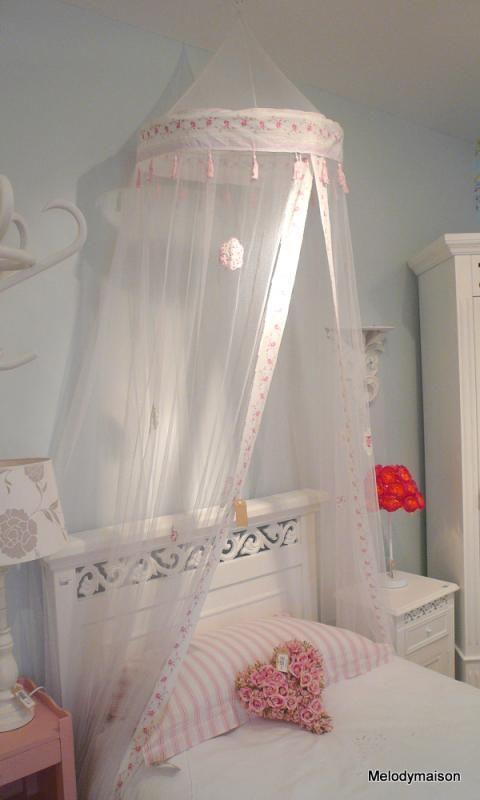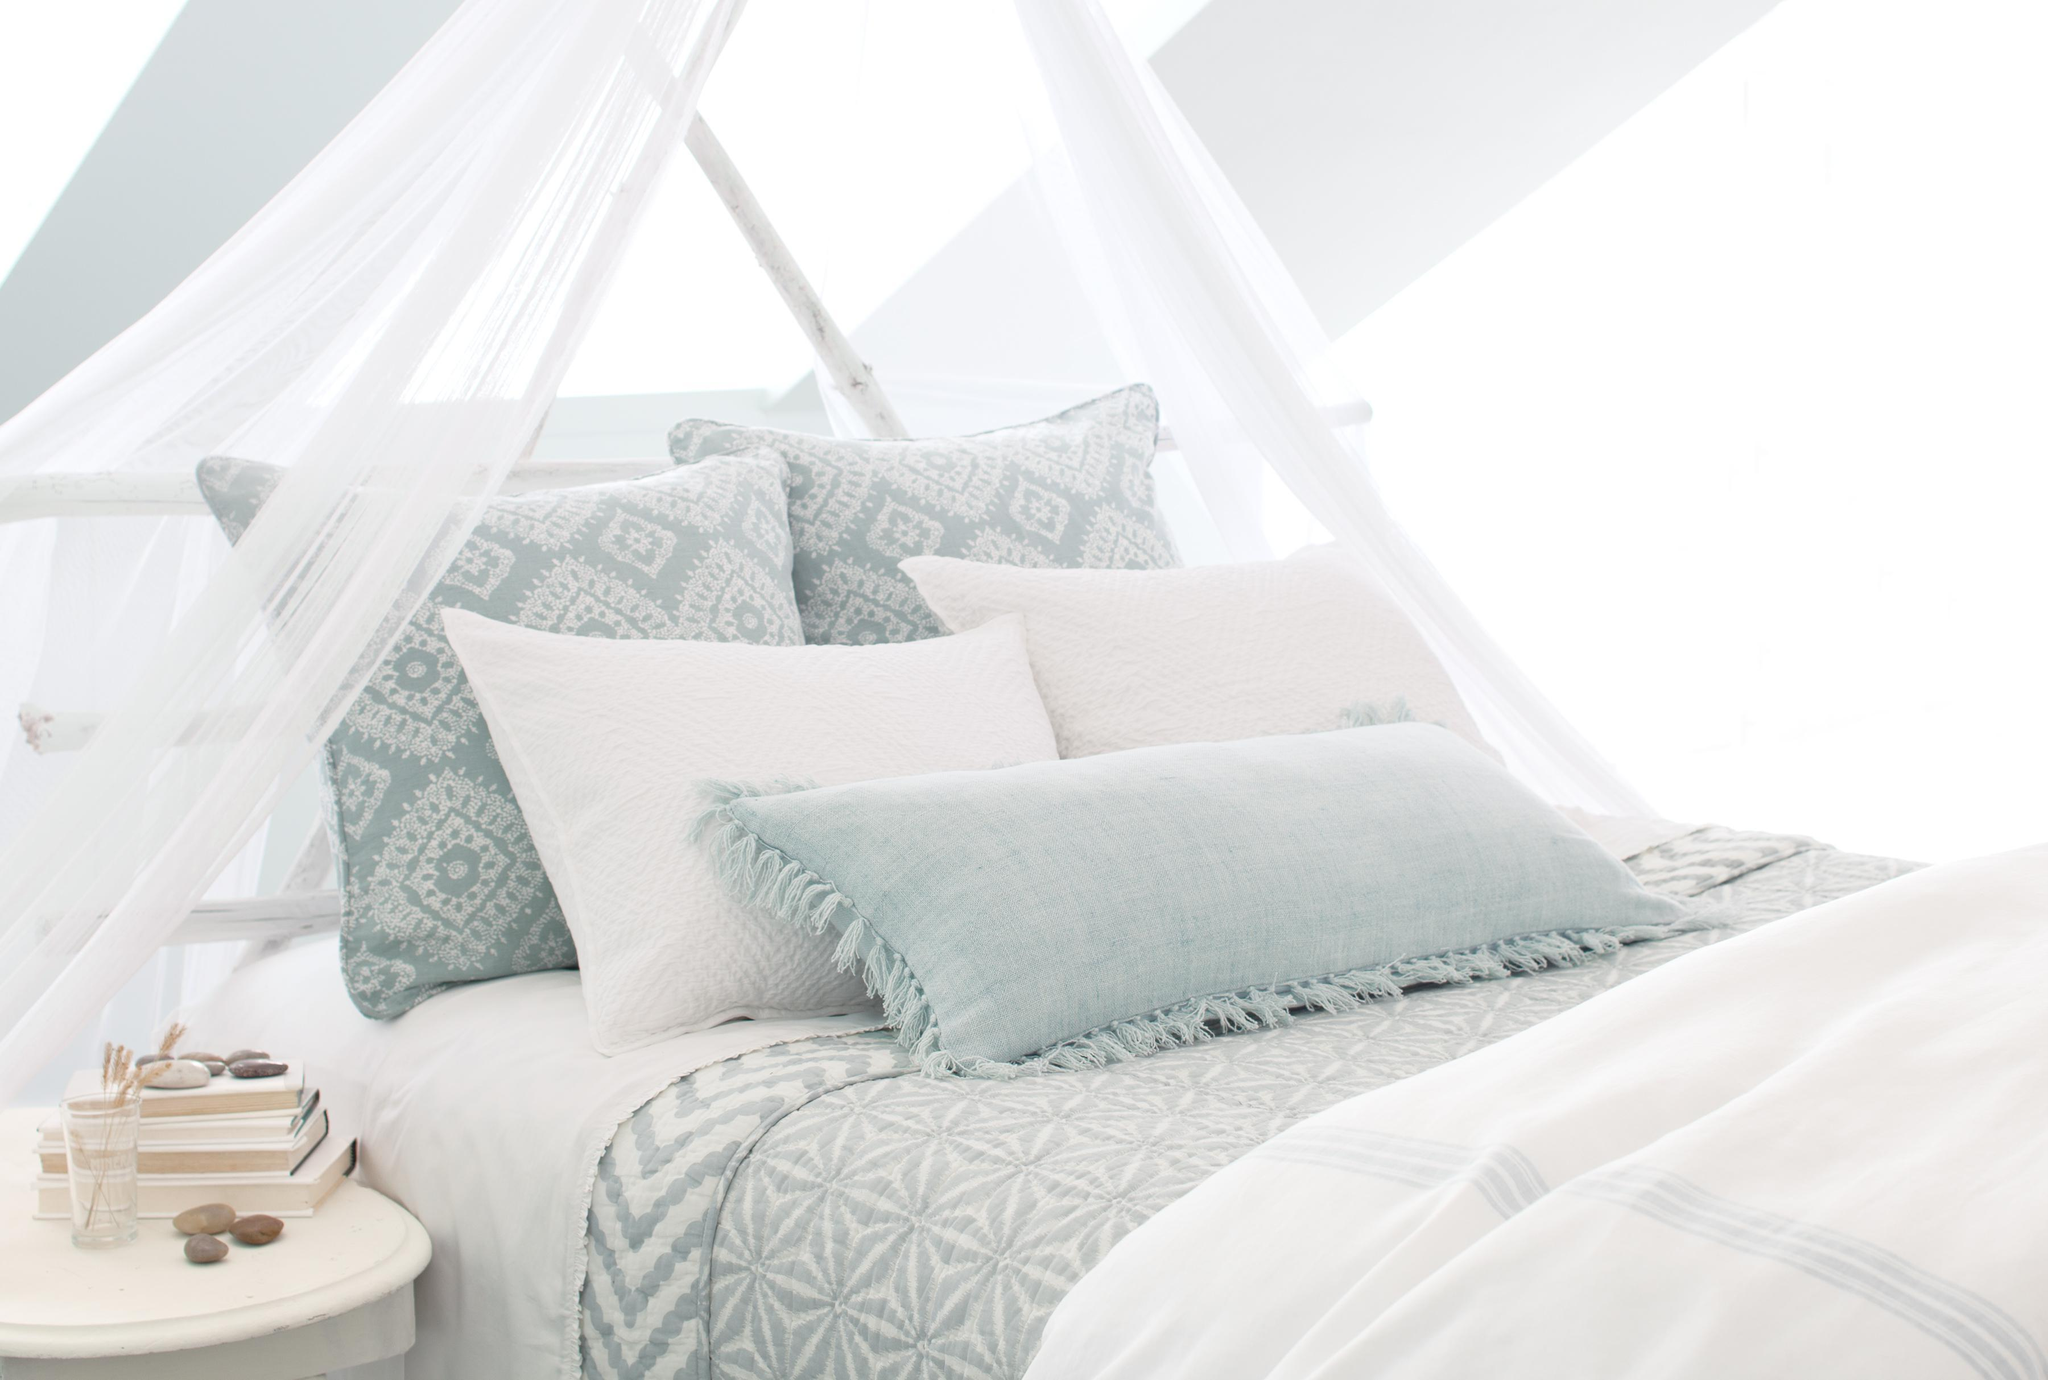The first image is the image on the left, the second image is the image on the right. For the images displayed, is the sentence "There are two bed with two white canopies." factually correct? Answer yes or no. Yes. The first image is the image on the left, the second image is the image on the right. For the images displayed, is the sentence "The right image shows at least one bed canopy, but no bed is shown." factually correct? Answer yes or no. No. 